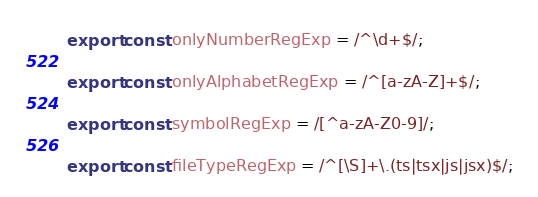<code> <loc_0><loc_0><loc_500><loc_500><_TypeScript_>export const onlyNumberRegExp = /^\d+$/;

export const onlyAlphabetRegExp = /^[a-zA-Z]+$/;

export const symbolRegExp = /[^a-zA-Z0-9]/;

export const fileTypeRegExp = /^[\S]+\.(ts|tsx|js|jsx)$/;
</code> 